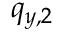Convert formula to latex. <formula><loc_0><loc_0><loc_500><loc_500>q _ { y , 2 }</formula> 